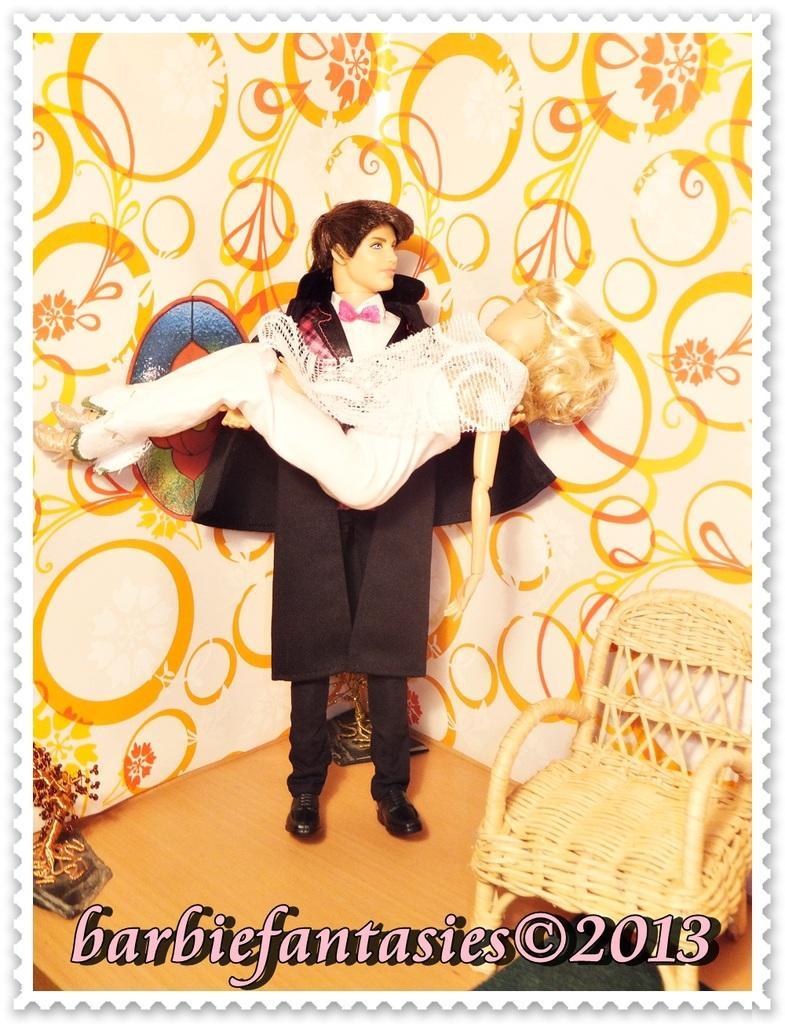Describe this image in one or two sentences. This picture seems to be an edited image. On the right we can see the chair and some objects are placed on the ground. In the center we can see the toy of a man wearing jacket and carrying the toy of a woman. In the background we can see an object seems to be the wall on which we can see the pictures of some objects. At the bottom we can see the text and numbers on the image. 